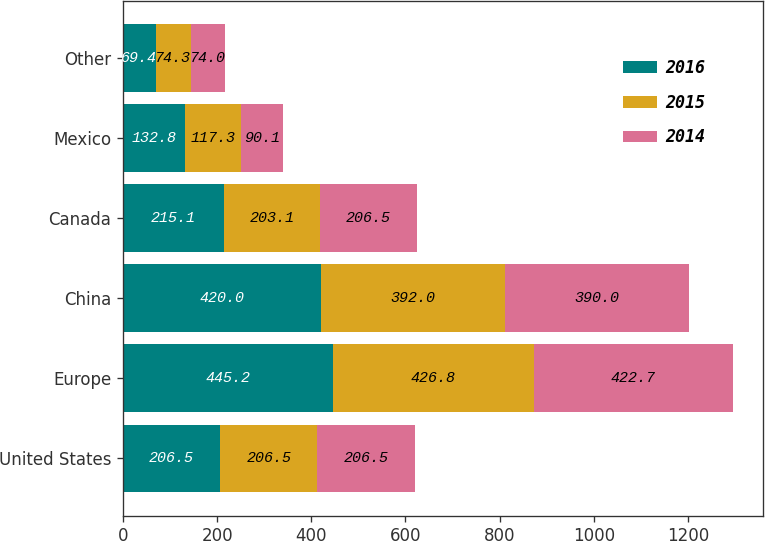Convert chart. <chart><loc_0><loc_0><loc_500><loc_500><stacked_bar_chart><ecel><fcel>United States<fcel>Europe<fcel>China<fcel>Canada<fcel>Mexico<fcel>Other<nl><fcel>2016<fcel>206.5<fcel>445.2<fcel>420<fcel>215.1<fcel>132.8<fcel>69.4<nl><fcel>2015<fcel>206.5<fcel>426.8<fcel>392<fcel>203.1<fcel>117.3<fcel>74.3<nl><fcel>2014<fcel>206.5<fcel>422.7<fcel>390<fcel>206.5<fcel>90.1<fcel>74<nl></chart> 